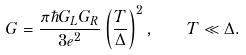Convert formula to latex. <formula><loc_0><loc_0><loc_500><loc_500>G = \frac { \pi \hbar { G } _ { L } G _ { R } } { 3 e ^ { 2 } } \left ( \frac { T } { \Delta } \right ) ^ { 2 } , \quad T \ll \Delta .</formula> 